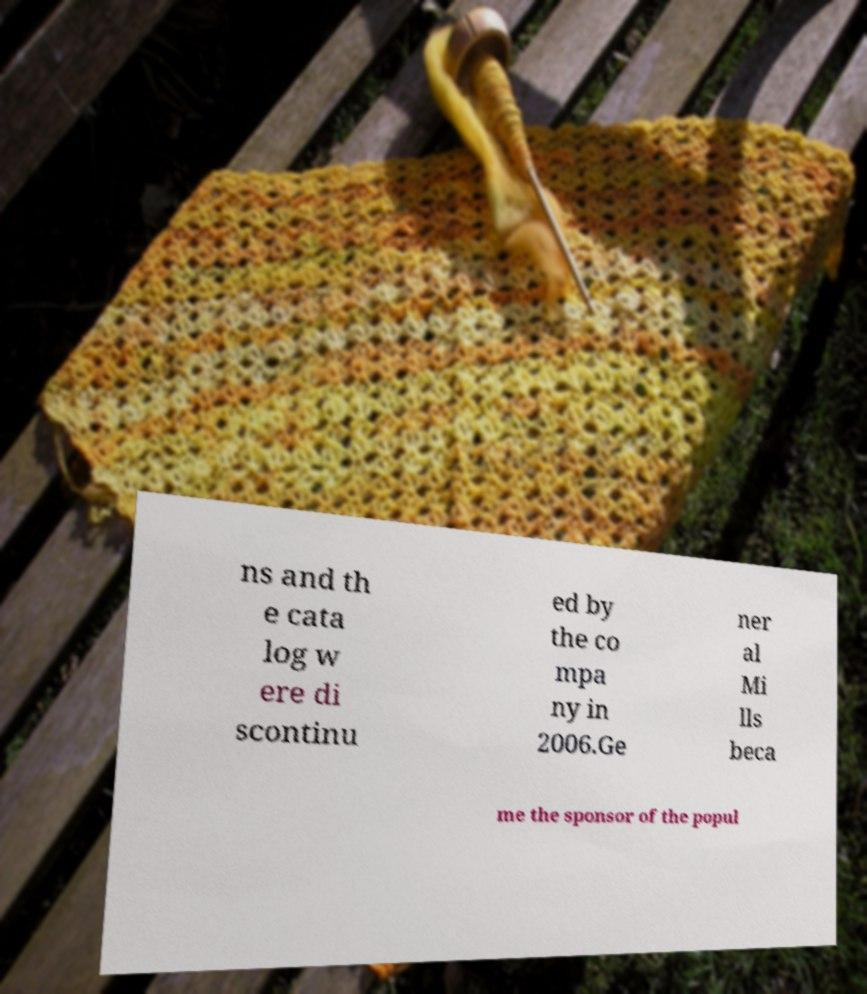Can you accurately transcribe the text from the provided image for me? ns and th e cata log w ere di scontinu ed by the co mpa ny in 2006.Ge ner al Mi lls beca me the sponsor of the popul 